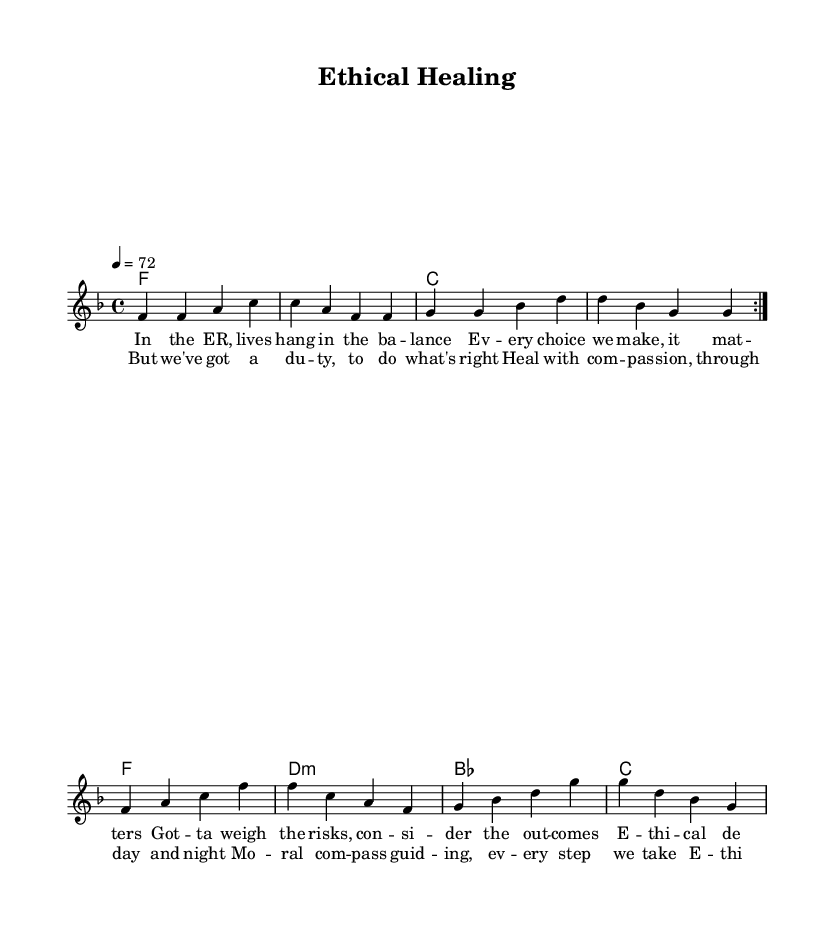What is the key signature of this music? The key signature shown in the global section indicates F major, which has one flat (B flat).
Answer: F major What is the time signature of this music? The time signature appears in the global section and is indicated as 4/4, meaning there are four beats in each measure.
Answer: 4/4 What is the tempo setting for this piece? The tempo is specified in the global section as 4 beats per minute at 72, indicating the speed at which the music should be played.
Answer: 72 How many times is the melody repeated in the first section? The repeat sign in the melody indicates that the first section of the melody is repeated twice as indicated by the volta markings.
Answer: 2 What is the primary theme of the lyrics? The lyrics focus on ethical decisions and the moral responsibilities of healthcare professionals, highlighting compassion and duty in their work.
Answer: Ethical responsibilities What chords are played in the last line of the piece? The last line of the harmonies indicates a series of chords played: F, D minor, B flat, and C. This represents the harmonic structure that supports the final lyrical message.
Answer: F, D minor, B flat, C Which musical genre does this piece represent? The style and instrumentation, along with the lyrical themes of compassion and moral responsibility, are characteristic of Rhythm and Blues music.
Answer: Rhythm and Blues 